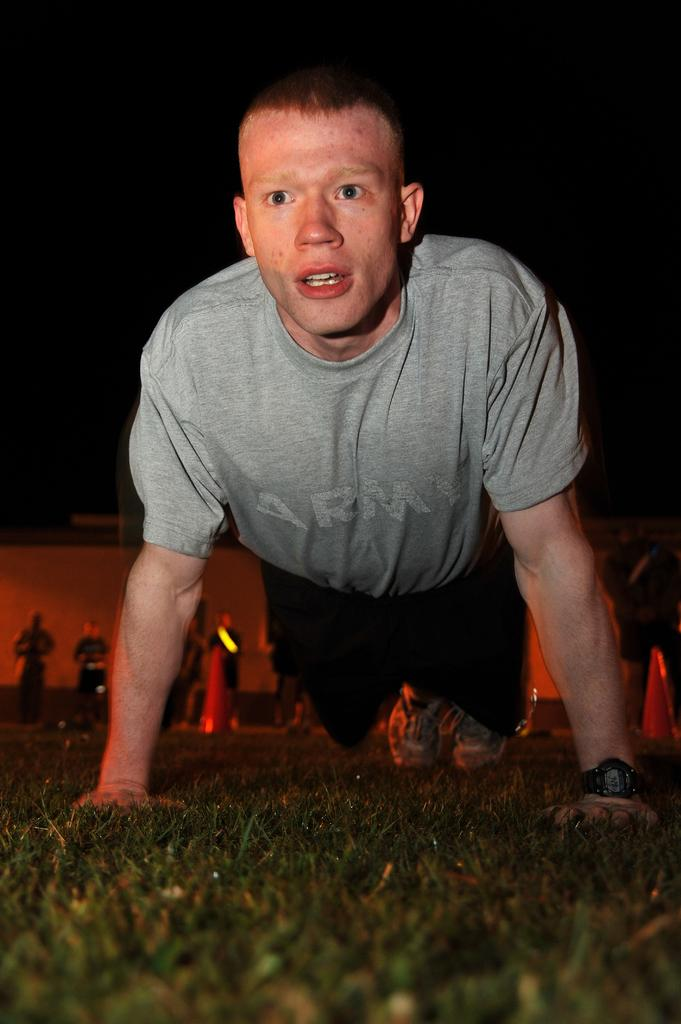What is the main subject of the image? The main subject of the image is a man. What is the man wearing in the image? The man is wearing a grey t-shirt in the image. What activity is the man performing in the image? The man is doing push-ups in the image. Where are the push-ups being performed? The push-ups are being performed on grassland in the image. Can you describe the background of the image? There are people standing in the background of the image. What type of seat can be seen in the bedroom in the image? There is no bedroom or seat present in the image; it features a man doing push-ups on grassland with people standing in the background. 